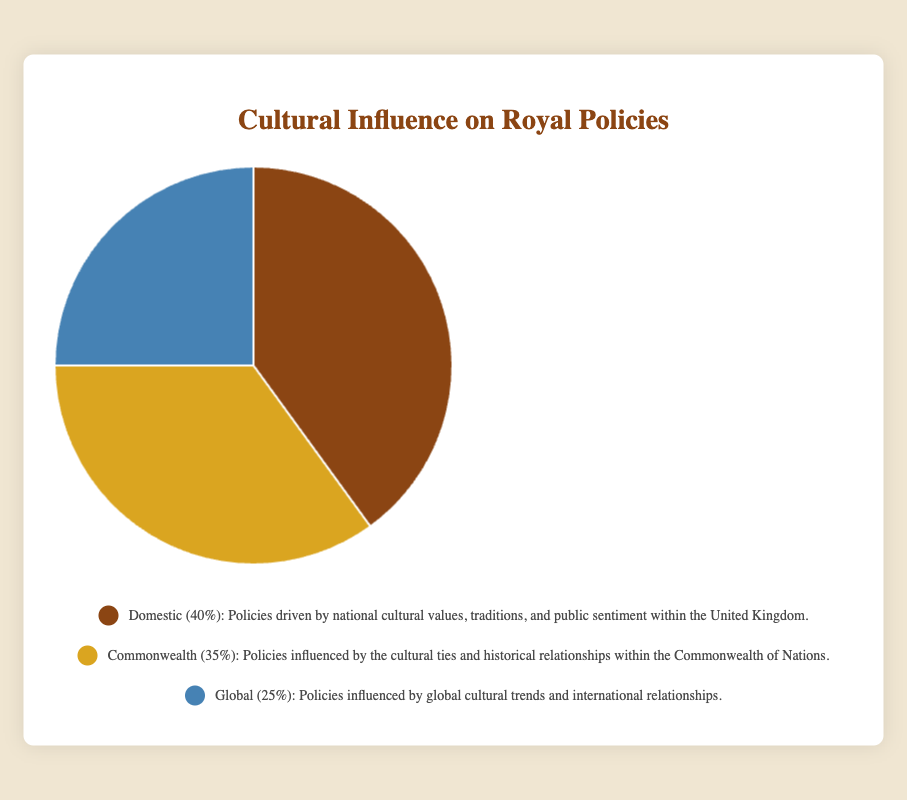What is the percentage of policies driven by domestic cultural values? The figure shows that the domestic sector, represented in brown, has a value of 40%, indicating that 40% of the policies are influenced by national cultural values within the United Kingdom.
Answer: 40% What is the difference in percentage between policies influenced by Commonwealth and Global cultural trends? From the figure, the Commonwealth sector (gold) accounts for 35%, while the Global sector (blue) accounts for 25%. The difference between these two is calculated as 35% - 25%.
Answer: 10% Which category has the smallest percentage influence on royal policies, and what is that percentage? The smallest segment on the pie chart is blue for the Global category, which has a value of 25%.
Answer: Global, 25% What is the combined percentage influence of Commonwealth and Global cultural trends on royal policies? The figure indicates that the Commonwealth sector contributes 35% and the Global sector contributes 25%. The combined influence is calculated by adding these two values together: 35% + 25%.
Answer: 60% If the total number of cultural policies is 100, how many policies are influenced by national cultural values? The Domestic sector (brown) represents 40% of the total policies. Therefore, if the total is 100 policies, the number of policies influenced by national cultural values is calculated by taking 40% of 100, which is 0.4 * 100.
Answer: 40 Is the influence of domestic cultural values greater or lesser than the combined influence of Commonwealth and Global cultural trends on royal policies? The Domestic sector is 40%, while the combined influence of Commonwealth (35%) and Global (25%) is 60%. Comparing 40% to 60%, it is clear that Domestic influence is lesser.
Answer: Lesser By how much does the influence of domestic cultural values exceed that of global cultural trends? The Domestic sector has a value of 40%, while the Global sector has a value of 25%. The difference between these two is calculated as 40% - 25%.
Answer: 15% What are the visual attributes (color and segment size) that represent policies influenced by Commonwealth cultural ties? In the pie chart, the Commonwealth sector is represented by a gold color and its segment size shows it accounts for 35% of the pie. This is a moderately large segment.
Answer: Gold, 35% How many categories represent the cultural influences on royal policies? The figure shows three distinct segments in the pie chart, each representing a different category of cultural influences: Domestic, Commonwealth, and Global.
Answer: 3 What is the average percentage influence of policies from each of the three categories? The percentages for the three categories are Domestic (40%), Commonwealth (35%), and Global (25%). The average percentage is calculated by summing these values and dividing by the number of categories: (40% + 35% + 25%) / 3.
Answer: 33.33% 